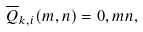<formula> <loc_0><loc_0><loc_500><loc_500>\overline { Q } _ { k , i } ( m , n ) = 0 , m n ,</formula> 